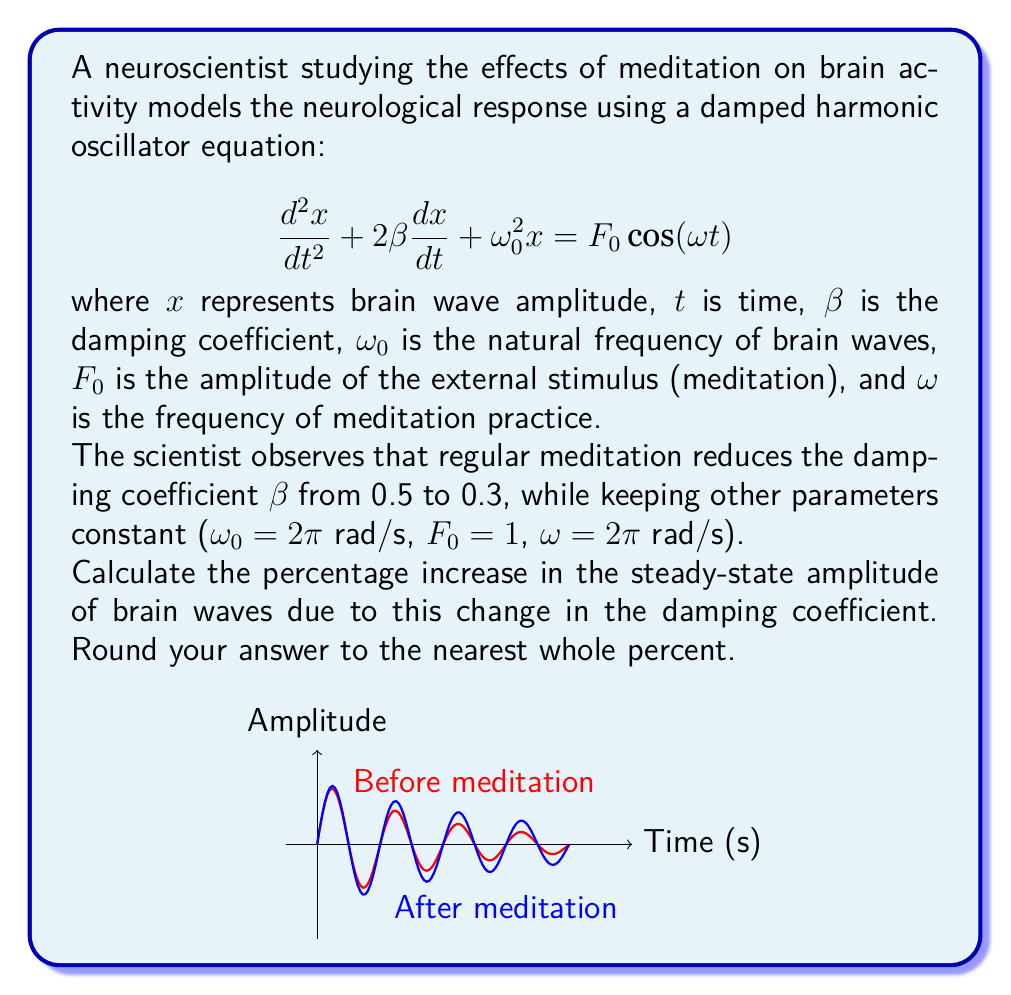Solve this math problem. Let's approach this step-by-step:

1) The steady-state amplitude for a damped harmonic oscillator is given by:

   $$A = \frac{F_0}{\sqrt{(\omega_0^2 - \omega^2)^2 + 4\beta^2\omega^2}}$$

2) We need to calculate this for both cases: $\beta = 0.5$ and $\beta = 0.3$

3) For $\beta = 0.5$:
   $$A_1 = \frac{1}{\sqrt{((2\pi)^2 - (2\pi)^2)^2 + 4(0.5)^2(2\pi)^2}}$$
   $$= \frac{1}{\sqrt{0^2 + 4(0.5)^2(2\pi)^2}} = \frac{1}{2\pi}$$

4) For $\beta = 0.3$:
   $$A_2 = \frac{1}{\sqrt{((2\pi)^2 - (2\pi)^2)^2 + 4(0.3)^2(2\pi)^2}}$$
   $$= \frac{1}{\sqrt{0^2 + 4(0.3)^2(2\pi)^2}} = \frac{1}{1.2\pi}$$

5) The percentage increase is:
   $$\text{Percentage Increase} = \frac{A_2 - A_1}{A_1} \times 100\%$$
   $$= \frac{\frac{1}{1.2\pi} - \frac{1}{2\pi}}{\frac{1}{2\pi}} \times 100\%$$
   $$= \frac{\frac{5}{6} - \frac{1}{2}}{\frac{1}{2}} \times 100\% = \frac{\frac{1}{3}}{\frac{1}{2}} \times 100\% = \frac{2}{3} \times 100\% \approx 66.67\%$$

6) Rounding to the nearest whole percent gives 67%.
Answer: 67% 